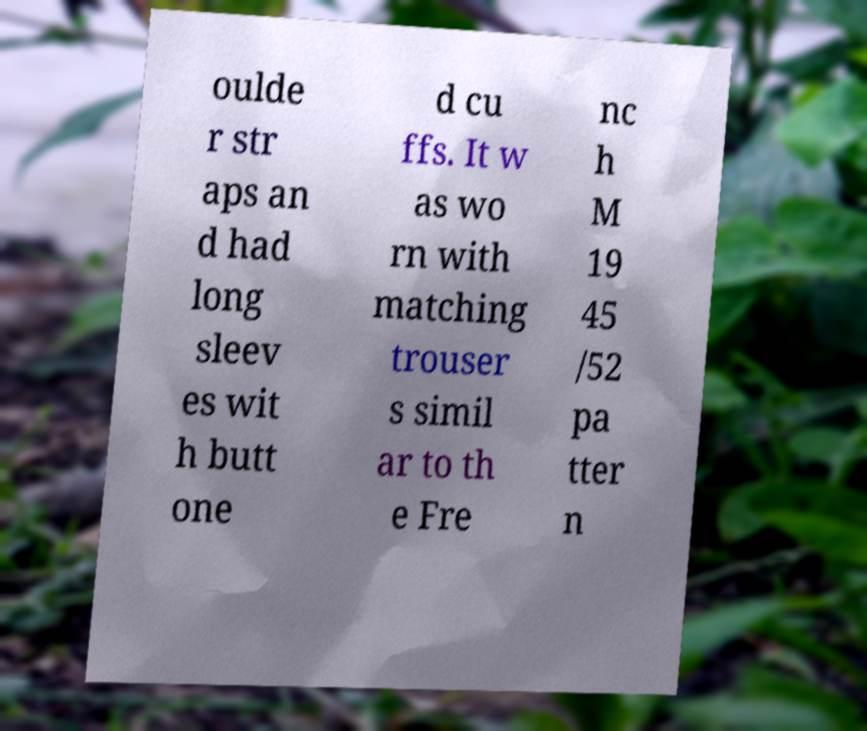Can you accurately transcribe the text from the provided image for me? oulde r str aps an d had long sleev es wit h butt one d cu ffs. It w as wo rn with matching trouser s simil ar to th e Fre nc h M 19 45 /52 pa tter n 